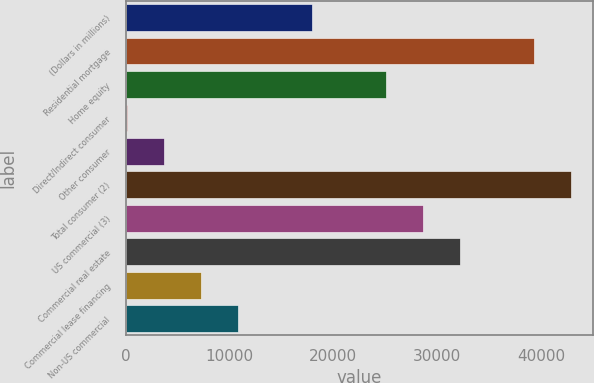Convert chart. <chart><loc_0><loc_0><loc_500><loc_500><bar_chart><fcel>(Dollars in millions)<fcel>Residential mortgage<fcel>Home equity<fcel>Direct/Indirect consumer<fcel>Other consumer<fcel>Total consumer (2)<fcel>US commercial (3)<fcel>Commercial real estate<fcel>Commercial lease financing<fcel>Non-US commercial<nl><fcel>17916.5<fcel>39313.1<fcel>25048.7<fcel>86<fcel>3652.1<fcel>42879.2<fcel>28614.8<fcel>32180.9<fcel>7218.2<fcel>10784.3<nl></chart> 